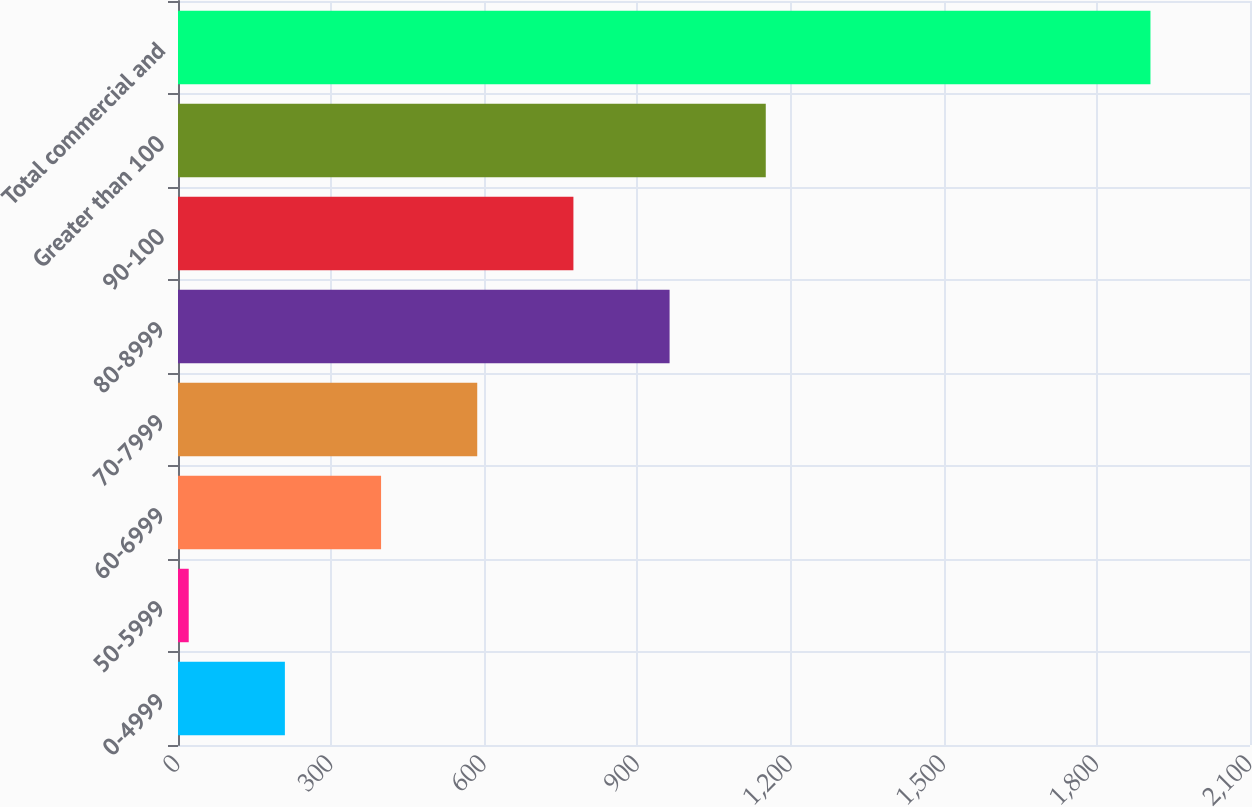Convert chart. <chart><loc_0><loc_0><loc_500><loc_500><bar_chart><fcel>0-4999<fcel>50-5999<fcel>60-6999<fcel>70-7999<fcel>80-8999<fcel>90-100<fcel>Greater than 100<fcel>Total commercial and<nl><fcel>209.4<fcel>21<fcel>397.8<fcel>586.2<fcel>963<fcel>774.6<fcel>1151.4<fcel>1905<nl></chart> 